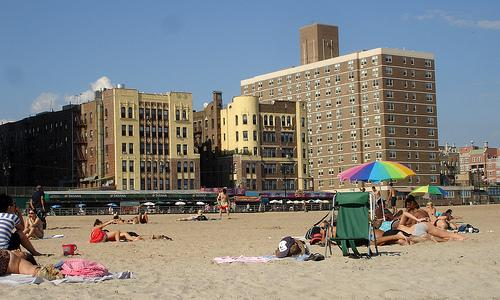Can you identify any objects that are unique to a beach setting in the image? A child's red sand pail, multi-colored umbrellas, and people sunbathing are some of the objects unique to a beach setting in the image. Describe any clothing items or styles mentioned in the image. A man is wearing jeans as he leaves the beach, a girl's shirt has stripes, and another man is wearing a black shirt. What type of sky is pictured in the image? The sky is blue with clouds visible in the background. Describe the buildings in the background of the image. In the background, there are older city buildings, a city apartment building hirise, and a light brown tall building with a chimney on top. What is one caption related to mobile phone usage in the image? Cell phone usage is always evident, as shown by at least one person using their phone. What is the main activity happening at the beach in the image? Family and friends are enjoying a day at their favorite beach, sitting under rainbow-colored umbrellas for sun protection. List a few descriptors associated with the sand in the image. The sand is described as white, covering a large part of the image, and people are sitting on it with their blankets and towels. Mention a few objects and their colors in the image. Some objects and their colors are a green chair, a pink blanket, white umbrellas, a red sand pail, and a black shirt on a man. Identify a caption about a person lying on a blanket and describe the blanket. A person is lying on a pink blanket which is spread out on the white sand at the beach. How are people protecting themselves from the sun in the image? People are using rainbow-colored and white umbrellas for sun protection while sitting or lying under them. 